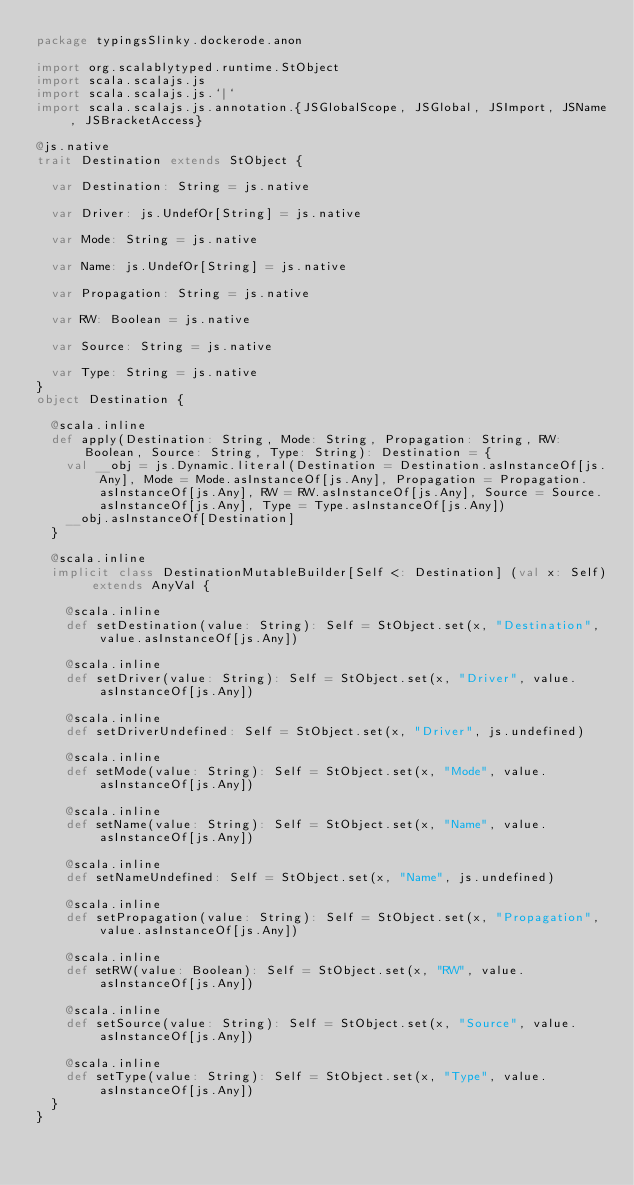<code> <loc_0><loc_0><loc_500><loc_500><_Scala_>package typingsSlinky.dockerode.anon

import org.scalablytyped.runtime.StObject
import scala.scalajs.js
import scala.scalajs.js.`|`
import scala.scalajs.js.annotation.{JSGlobalScope, JSGlobal, JSImport, JSName, JSBracketAccess}

@js.native
trait Destination extends StObject {
  
  var Destination: String = js.native
  
  var Driver: js.UndefOr[String] = js.native
  
  var Mode: String = js.native
  
  var Name: js.UndefOr[String] = js.native
  
  var Propagation: String = js.native
  
  var RW: Boolean = js.native
  
  var Source: String = js.native
  
  var Type: String = js.native
}
object Destination {
  
  @scala.inline
  def apply(Destination: String, Mode: String, Propagation: String, RW: Boolean, Source: String, Type: String): Destination = {
    val __obj = js.Dynamic.literal(Destination = Destination.asInstanceOf[js.Any], Mode = Mode.asInstanceOf[js.Any], Propagation = Propagation.asInstanceOf[js.Any], RW = RW.asInstanceOf[js.Any], Source = Source.asInstanceOf[js.Any], Type = Type.asInstanceOf[js.Any])
    __obj.asInstanceOf[Destination]
  }
  
  @scala.inline
  implicit class DestinationMutableBuilder[Self <: Destination] (val x: Self) extends AnyVal {
    
    @scala.inline
    def setDestination(value: String): Self = StObject.set(x, "Destination", value.asInstanceOf[js.Any])
    
    @scala.inline
    def setDriver(value: String): Self = StObject.set(x, "Driver", value.asInstanceOf[js.Any])
    
    @scala.inline
    def setDriverUndefined: Self = StObject.set(x, "Driver", js.undefined)
    
    @scala.inline
    def setMode(value: String): Self = StObject.set(x, "Mode", value.asInstanceOf[js.Any])
    
    @scala.inline
    def setName(value: String): Self = StObject.set(x, "Name", value.asInstanceOf[js.Any])
    
    @scala.inline
    def setNameUndefined: Self = StObject.set(x, "Name", js.undefined)
    
    @scala.inline
    def setPropagation(value: String): Self = StObject.set(x, "Propagation", value.asInstanceOf[js.Any])
    
    @scala.inline
    def setRW(value: Boolean): Self = StObject.set(x, "RW", value.asInstanceOf[js.Any])
    
    @scala.inline
    def setSource(value: String): Self = StObject.set(x, "Source", value.asInstanceOf[js.Any])
    
    @scala.inline
    def setType(value: String): Self = StObject.set(x, "Type", value.asInstanceOf[js.Any])
  }
}
</code> 